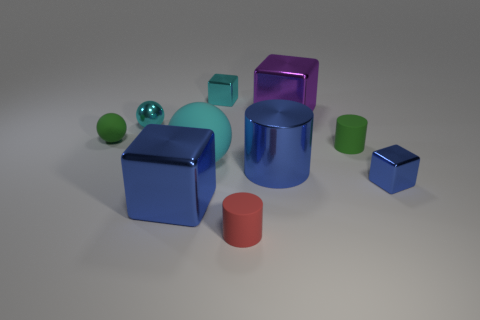There is a red cylinder that is made of the same material as the large cyan sphere; what size is it?
Provide a succinct answer. Small. Is the color of the tiny ball that is behind the green ball the same as the large matte object?
Give a very brief answer. Yes. What number of other things are there of the same shape as the big matte thing?
Make the answer very short. 2. Is the blue cylinder made of the same material as the cyan cube?
Offer a terse response. Yes. What material is the large thing that is both behind the shiny cylinder and left of the big purple object?
Provide a short and direct response. Rubber. There is a large object that is in front of the small blue metal object; what color is it?
Ensure brevity in your answer.  Blue. Is the number of large blue blocks left of the tiny green matte cylinder greater than the number of cyan cylinders?
Your response must be concise. Yes. How many other objects are there of the same size as the shiny sphere?
Your response must be concise. 5. There is a cyan rubber thing; how many cyan rubber things are in front of it?
Provide a succinct answer. 0. Are there an equal number of small red cylinders that are in front of the purple block and tiny cyan blocks right of the small matte ball?
Give a very brief answer. Yes. 